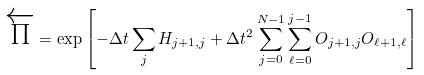Convert formula to latex. <formula><loc_0><loc_0><loc_500><loc_500>\overleftarrow { \Pi } = \exp \left [ - \Delta t \sum _ { j } H _ { j + 1 , j } + \Delta t ^ { 2 } \sum _ { j = 0 } ^ { N - 1 } \sum _ { \ell = 0 } ^ { j - 1 } O _ { j + 1 , j } O _ { \ell + 1 , \ell } \right ]</formula> 